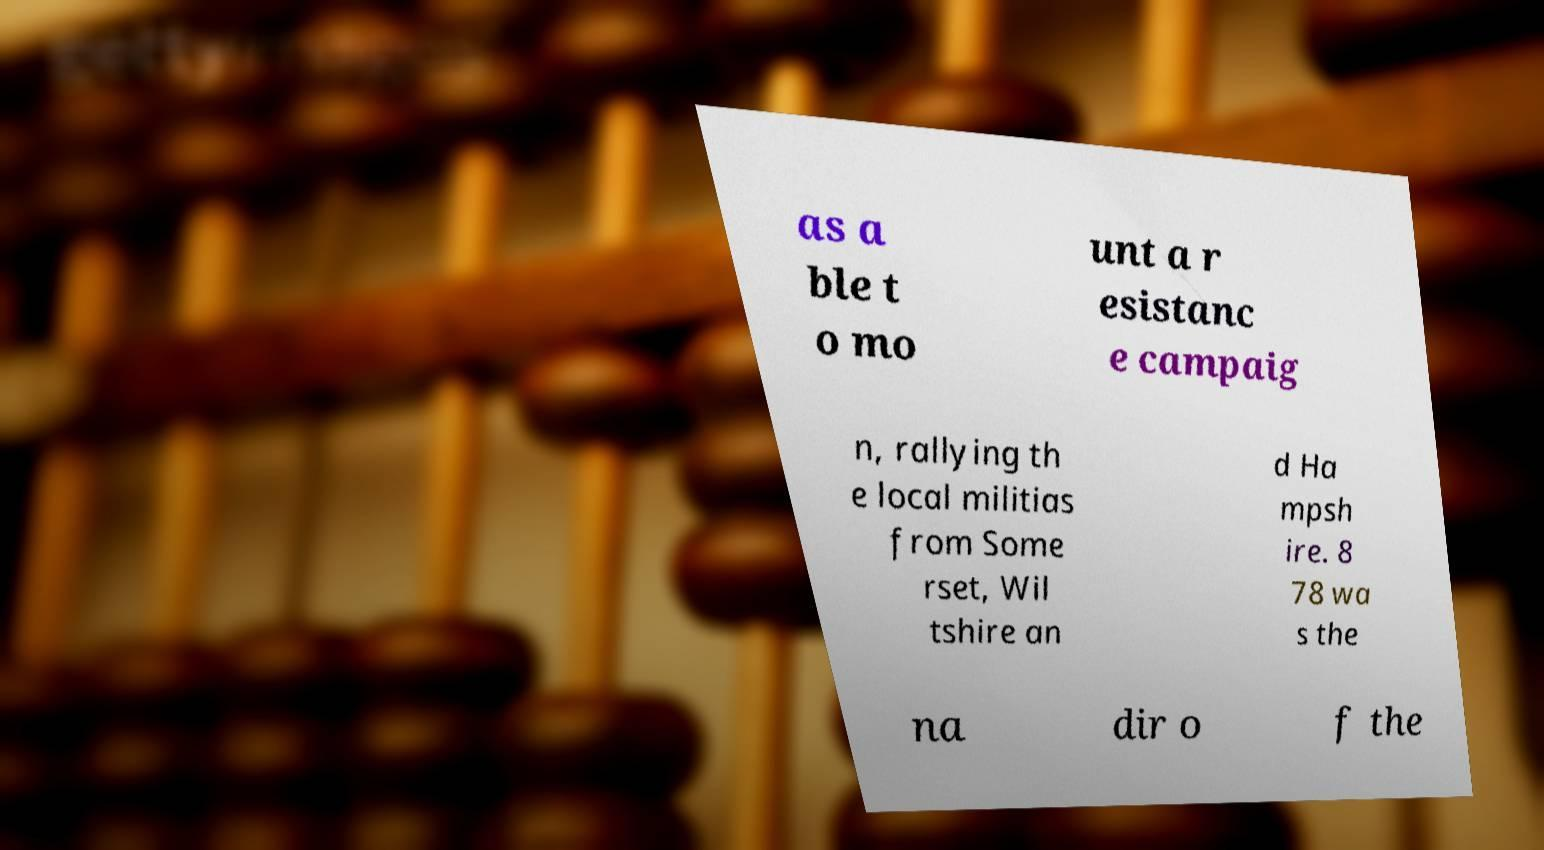I need the written content from this picture converted into text. Can you do that? as a ble t o mo unt a r esistanc e campaig n, rallying th e local militias from Some rset, Wil tshire an d Ha mpsh ire. 8 78 wa s the na dir o f the 